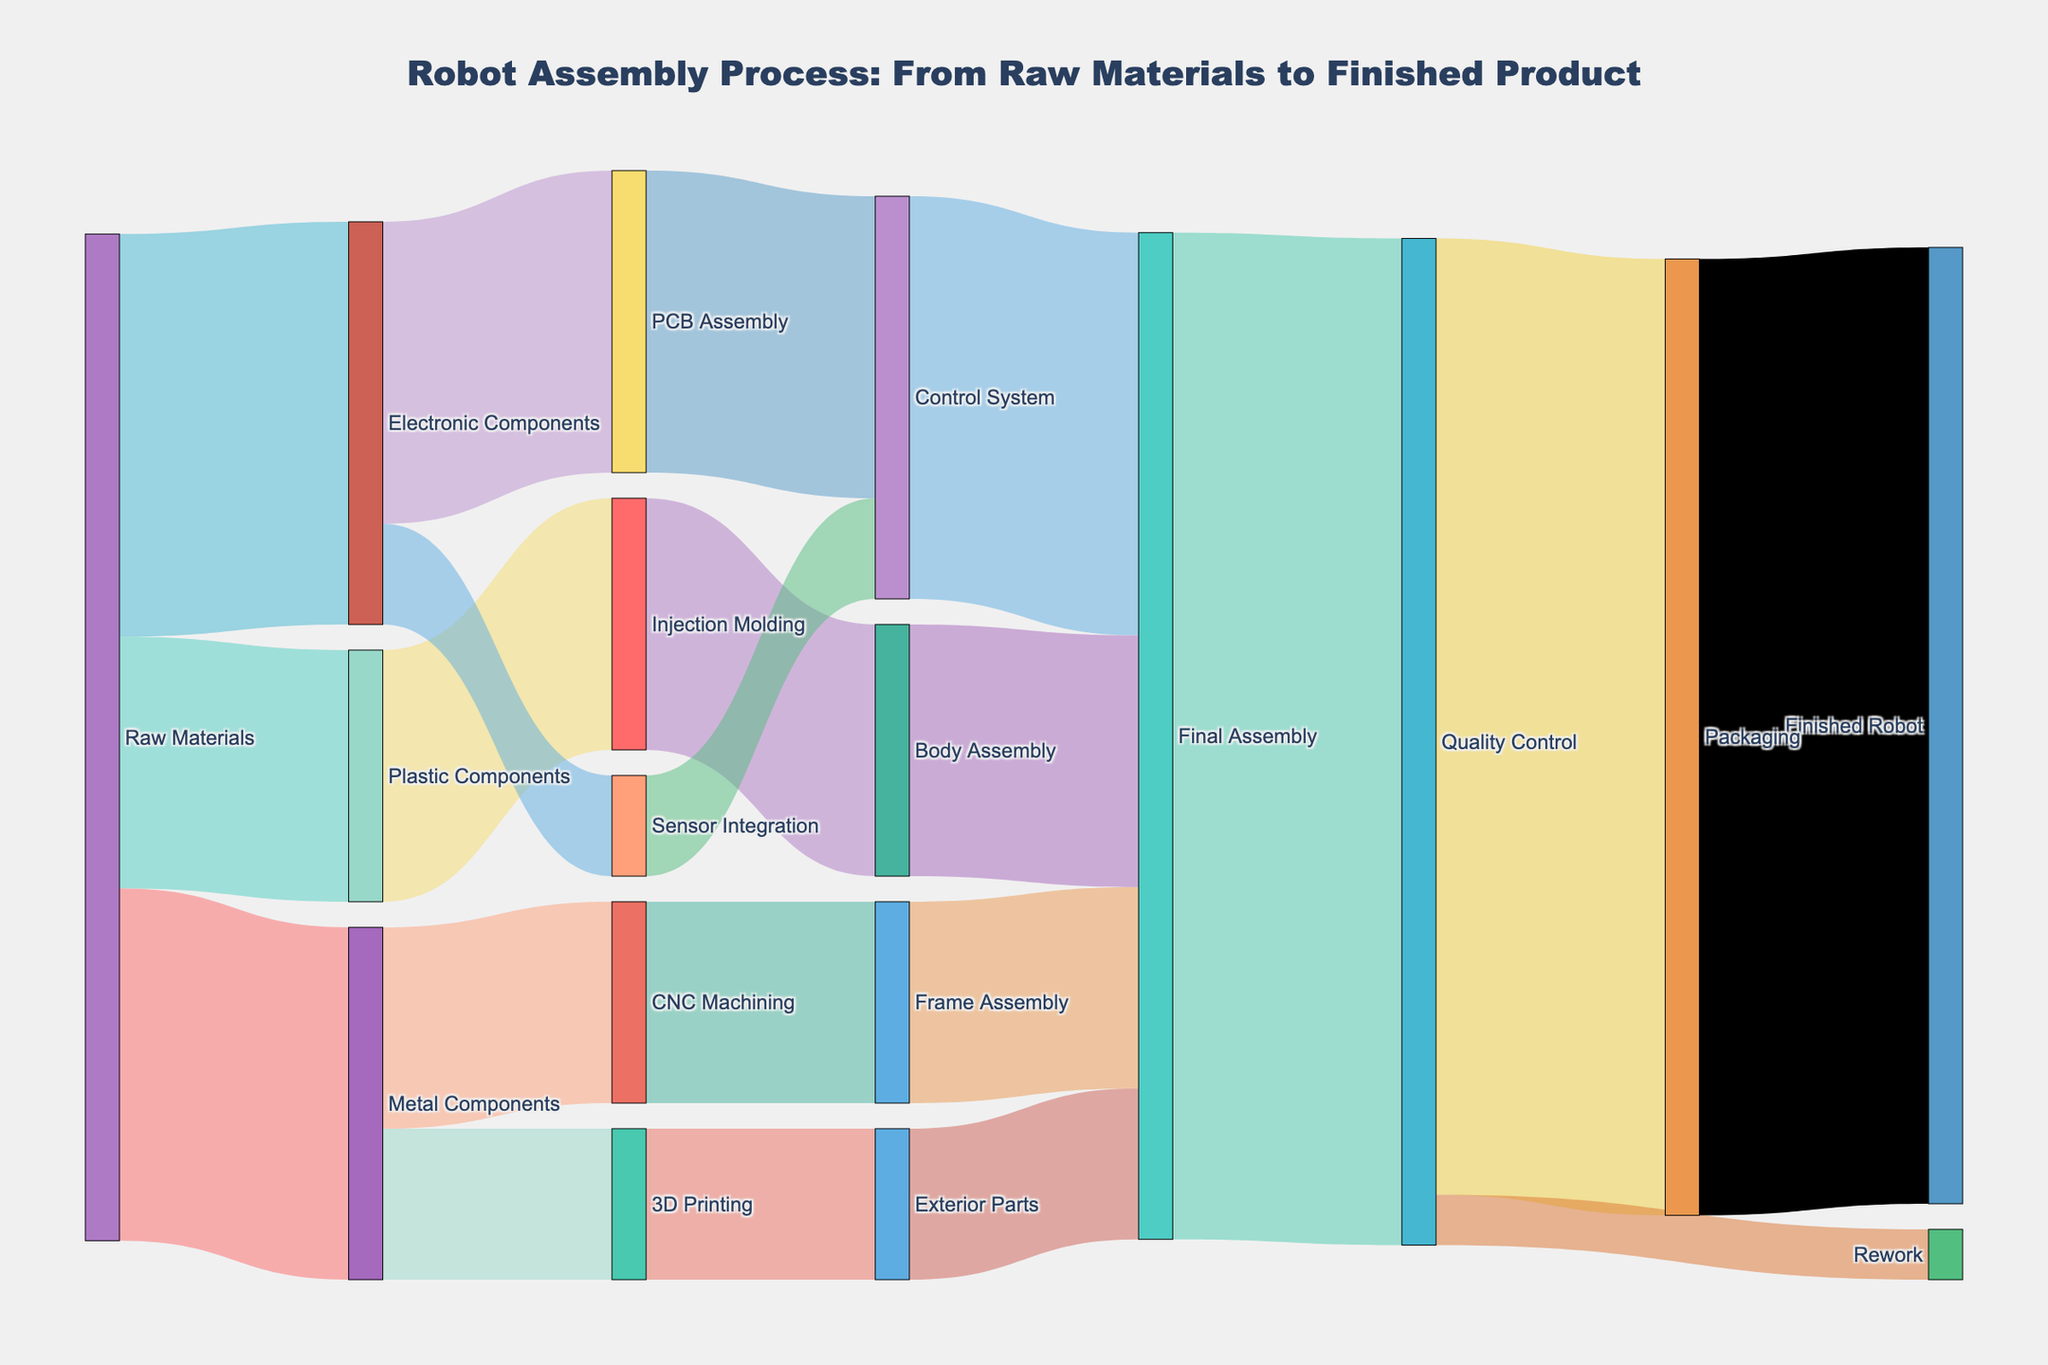Which process consumes the most electronic components? In the diagram, follow the flow from "Electronic Components" and compare the values leading to "PCB Assembly" (30) and "Sensor Integration" (10). "PCB Assembly" has the higher value.
Answer: PCB Assembly How many components go through CNC Machining? Follow the flow from "Metal Components" to "CNC Machining." The value is stated directly.
Answer: 20 What is the final step before the robot is packaged? Trace the path from "Final Assembly" to "Quality Control" and then "Packaging." The step immediately before "Packaging" is "Quality Control."
Answer: Quality Control After Control System, which process occurs next? Trace the flow from "Control System" to the next step. According to the diagram, it goes to "Final Assembly."
Answer: Final Assembly Which process uses more raw materials, Metal Components or Plastic Components? Compare the values leading to "Metal Components" (35) and "Plastic Components" (25) from "Raw Materials."
Answer: Metal Components What's the total value of materials reaching Final Assembly? Add the values leading to "Final Assembly" from various sources: "Frame Assembly" (20), "Exterior Parts" (15), "Body Assembly" (25), and "Control System" (40). The sum is 20 + 15 + 25 + 40 = 100.
Answer: 100 How many processes directly follow Raw Materials? Count the distinct processes that have direct lines from "Raw Materials" (Metal Components, Plastic Components, Electronic Components). There are 3.
Answer: 3 Which component process leads directly to Frame Assembly? Trace the paths leading to "Frame Assembly." It is directly preceded by "CNC Machining."
Answer: CNC Machining What happens if any component fails Quality Control? From "Quality Control," follow the secondary path which shows "Rework" as the next step.
Answer: Rework Between Injection Molding and 3D Printing, which produces more components? Compare the values leading to "Injection Molding" (25) and "3D Printing" (15) from their respective sources.
Answer: Injection Molding 